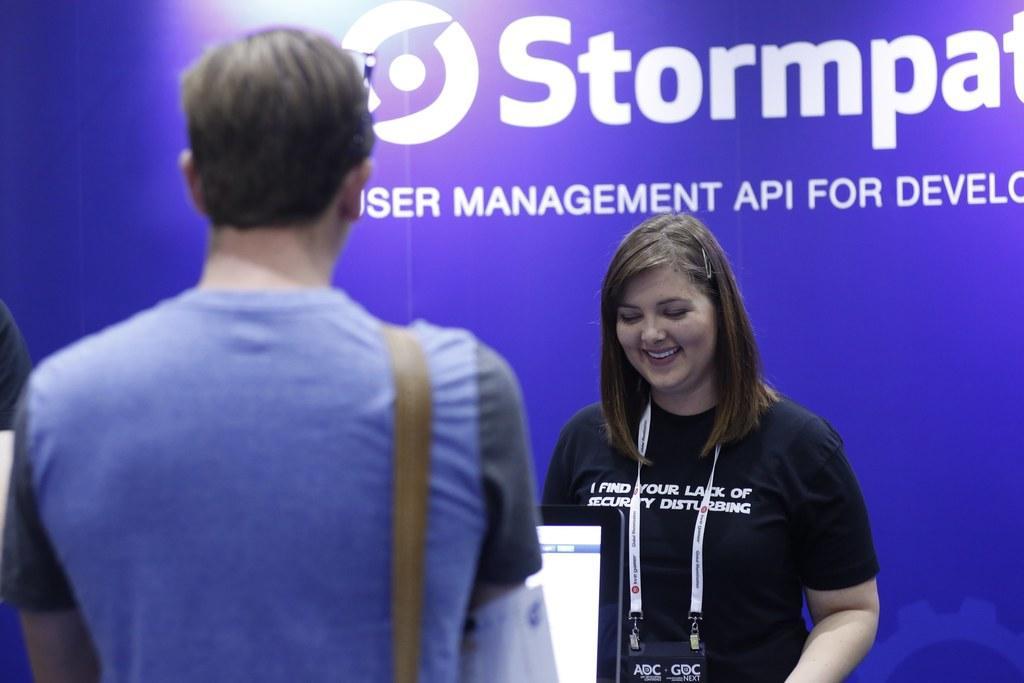Please provide a concise description of this image. In this image in the left there is a man. In front of him there is a screen. In the right a lady is smiling. She is wearing black t-shirt. In the background there is a banner. 